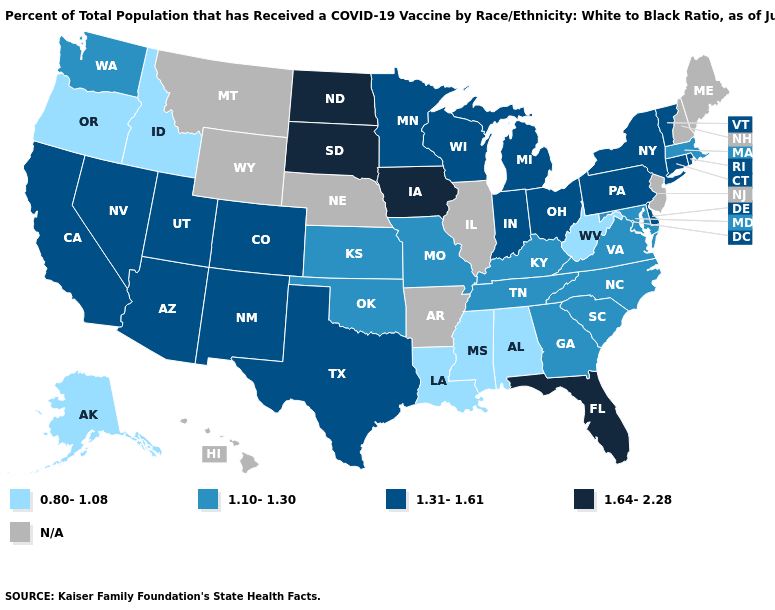Which states have the lowest value in the West?
Quick response, please. Alaska, Idaho, Oregon. What is the value of Connecticut?
Short answer required. 1.31-1.61. Is the legend a continuous bar?
Concise answer only. No. Name the states that have a value in the range 1.10-1.30?
Short answer required. Georgia, Kansas, Kentucky, Maryland, Massachusetts, Missouri, North Carolina, Oklahoma, South Carolina, Tennessee, Virginia, Washington. What is the value of Alaska?
Be succinct. 0.80-1.08. What is the highest value in the USA?
Concise answer only. 1.64-2.28. Name the states that have a value in the range 1.64-2.28?
Quick response, please. Florida, Iowa, North Dakota, South Dakota. Name the states that have a value in the range N/A?
Short answer required. Arkansas, Hawaii, Illinois, Maine, Montana, Nebraska, New Hampshire, New Jersey, Wyoming. What is the value of Maine?
Give a very brief answer. N/A. Name the states that have a value in the range 1.10-1.30?
Write a very short answer. Georgia, Kansas, Kentucky, Maryland, Massachusetts, Missouri, North Carolina, Oklahoma, South Carolina, Tennessee, Virginia, Washington. What is the lowest value in states that border Minnesota?
Short answer required. 1.31-1.61. Name the states that have a value in the range 1.64-2.28?
Quick response, please. Florida, Iowa, North Dakota, South Dakota. Does the first symbol in the legend represent the smallest category?
Keep it brief. Yes. Among the states that border Rhode Island , which have the highest value?
Quick response, please. Connecticut. Among the states that border Oklahoma , does Missouri have the highest value?
Write a very short answer. No. 